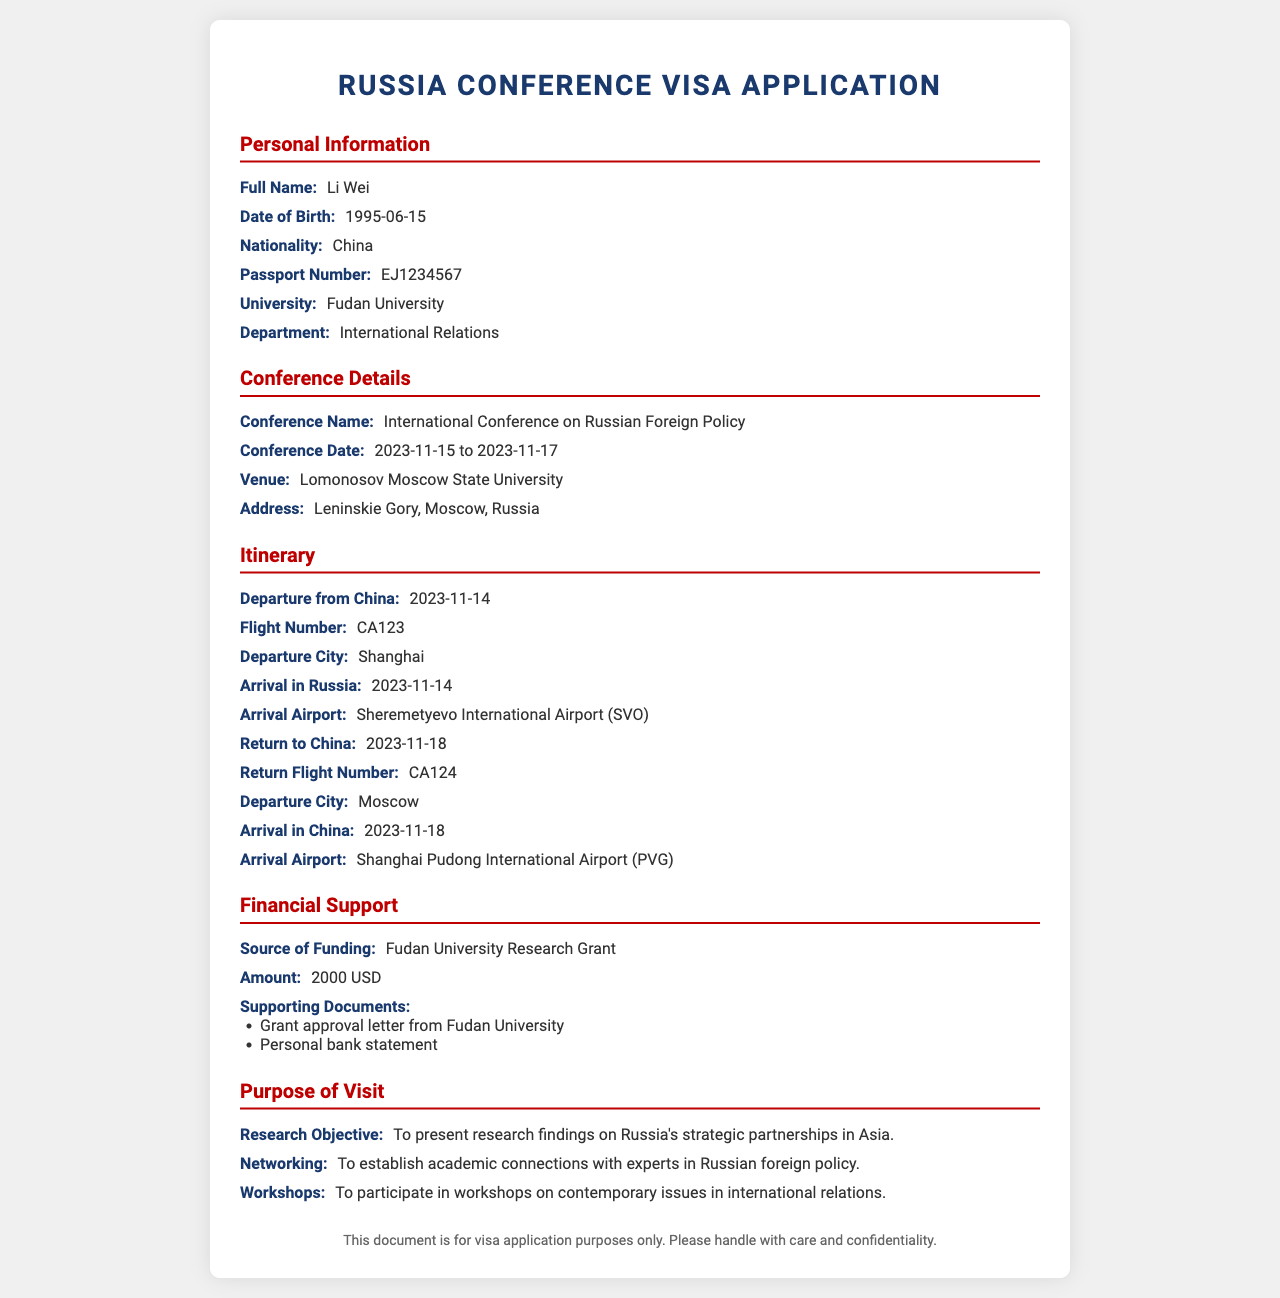What is the full name of the applicant? The full name of the applicant is listed under Personal Information as Li Wei.
Answer: Li Wei What is the nationality of the applicant? The nationality is stated in the document under Personal Information, which is China.
Answer: China When is the conference taking place? The conference dates are found in the Conference Details section, which specifies from 2023-11-15 to 2023-11-17.
Answer: 2023-11-15 to 2023-11-17 What is the source of funding for the visa application? The source of funding is provided in the Financial Support section where it mentions Fudan University Research Grant.
Answer: Fudan University Research Grant What is the research objective of the applicant? The research objective can be found in the Purpose of Visit section, stating it aims to present research findings on Russia's strategic partnerships in Asia.
Answer: To present research findings on Russia's strategic partnerships in Asia What is the departure date from China? The departure date is outlined in the Itinerary section as 2023-11-14.
Answer: 2023-11-14 What supporting documents are included for financial support? The supporting documents are listed in the Financial Support section, mentioning a grant approval letter and a personal bank statement.
Answer: Grant approval letter from Fudan University, Personal bank statement What is the return flight number? The return flight number is given in the Itinerary section as CA124.
Answer: CA124 Where is the conference venue located? The venue address is specified in the Conference Details section as Lomonosov Moscow State University, Leninskie Gory, Moscow, Russia.
Answer: Lomonosov Moscow State University, Leninskie Gory, Moscow, Russia 